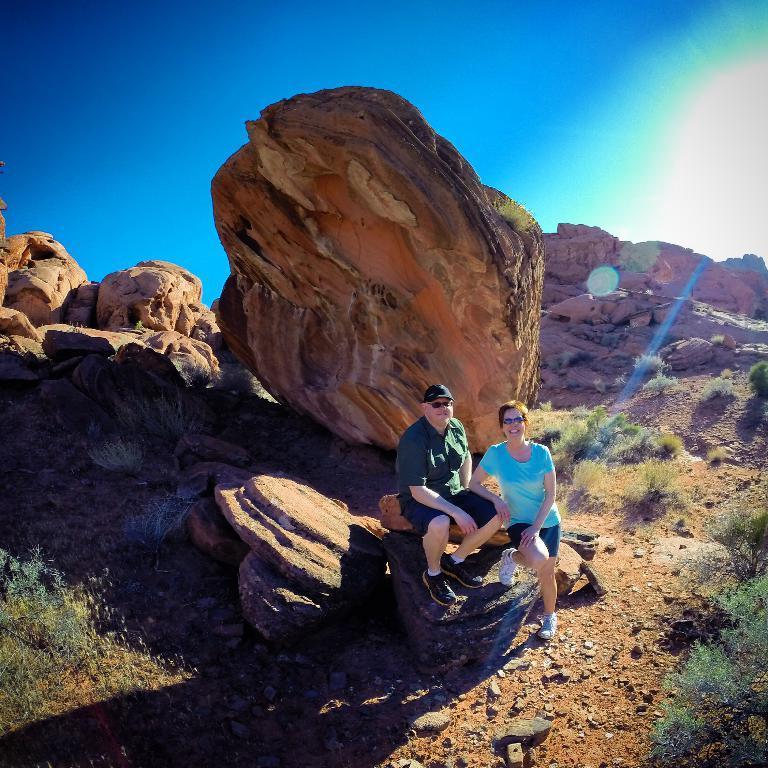Could you give a brief overview of what you see in this image? In this image I can see there is a man and a woman standing and there is a rock behind them, there are few plants, soil, stones and there are few rocks in the backdrop and the sky is clear. 